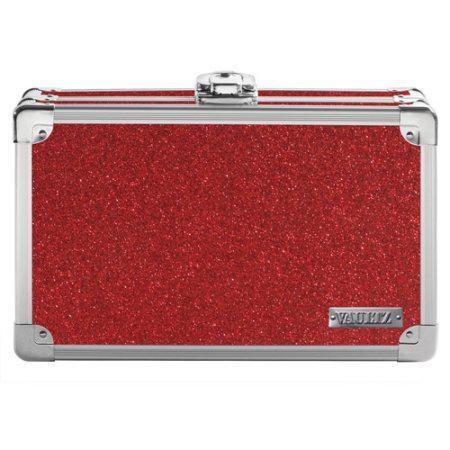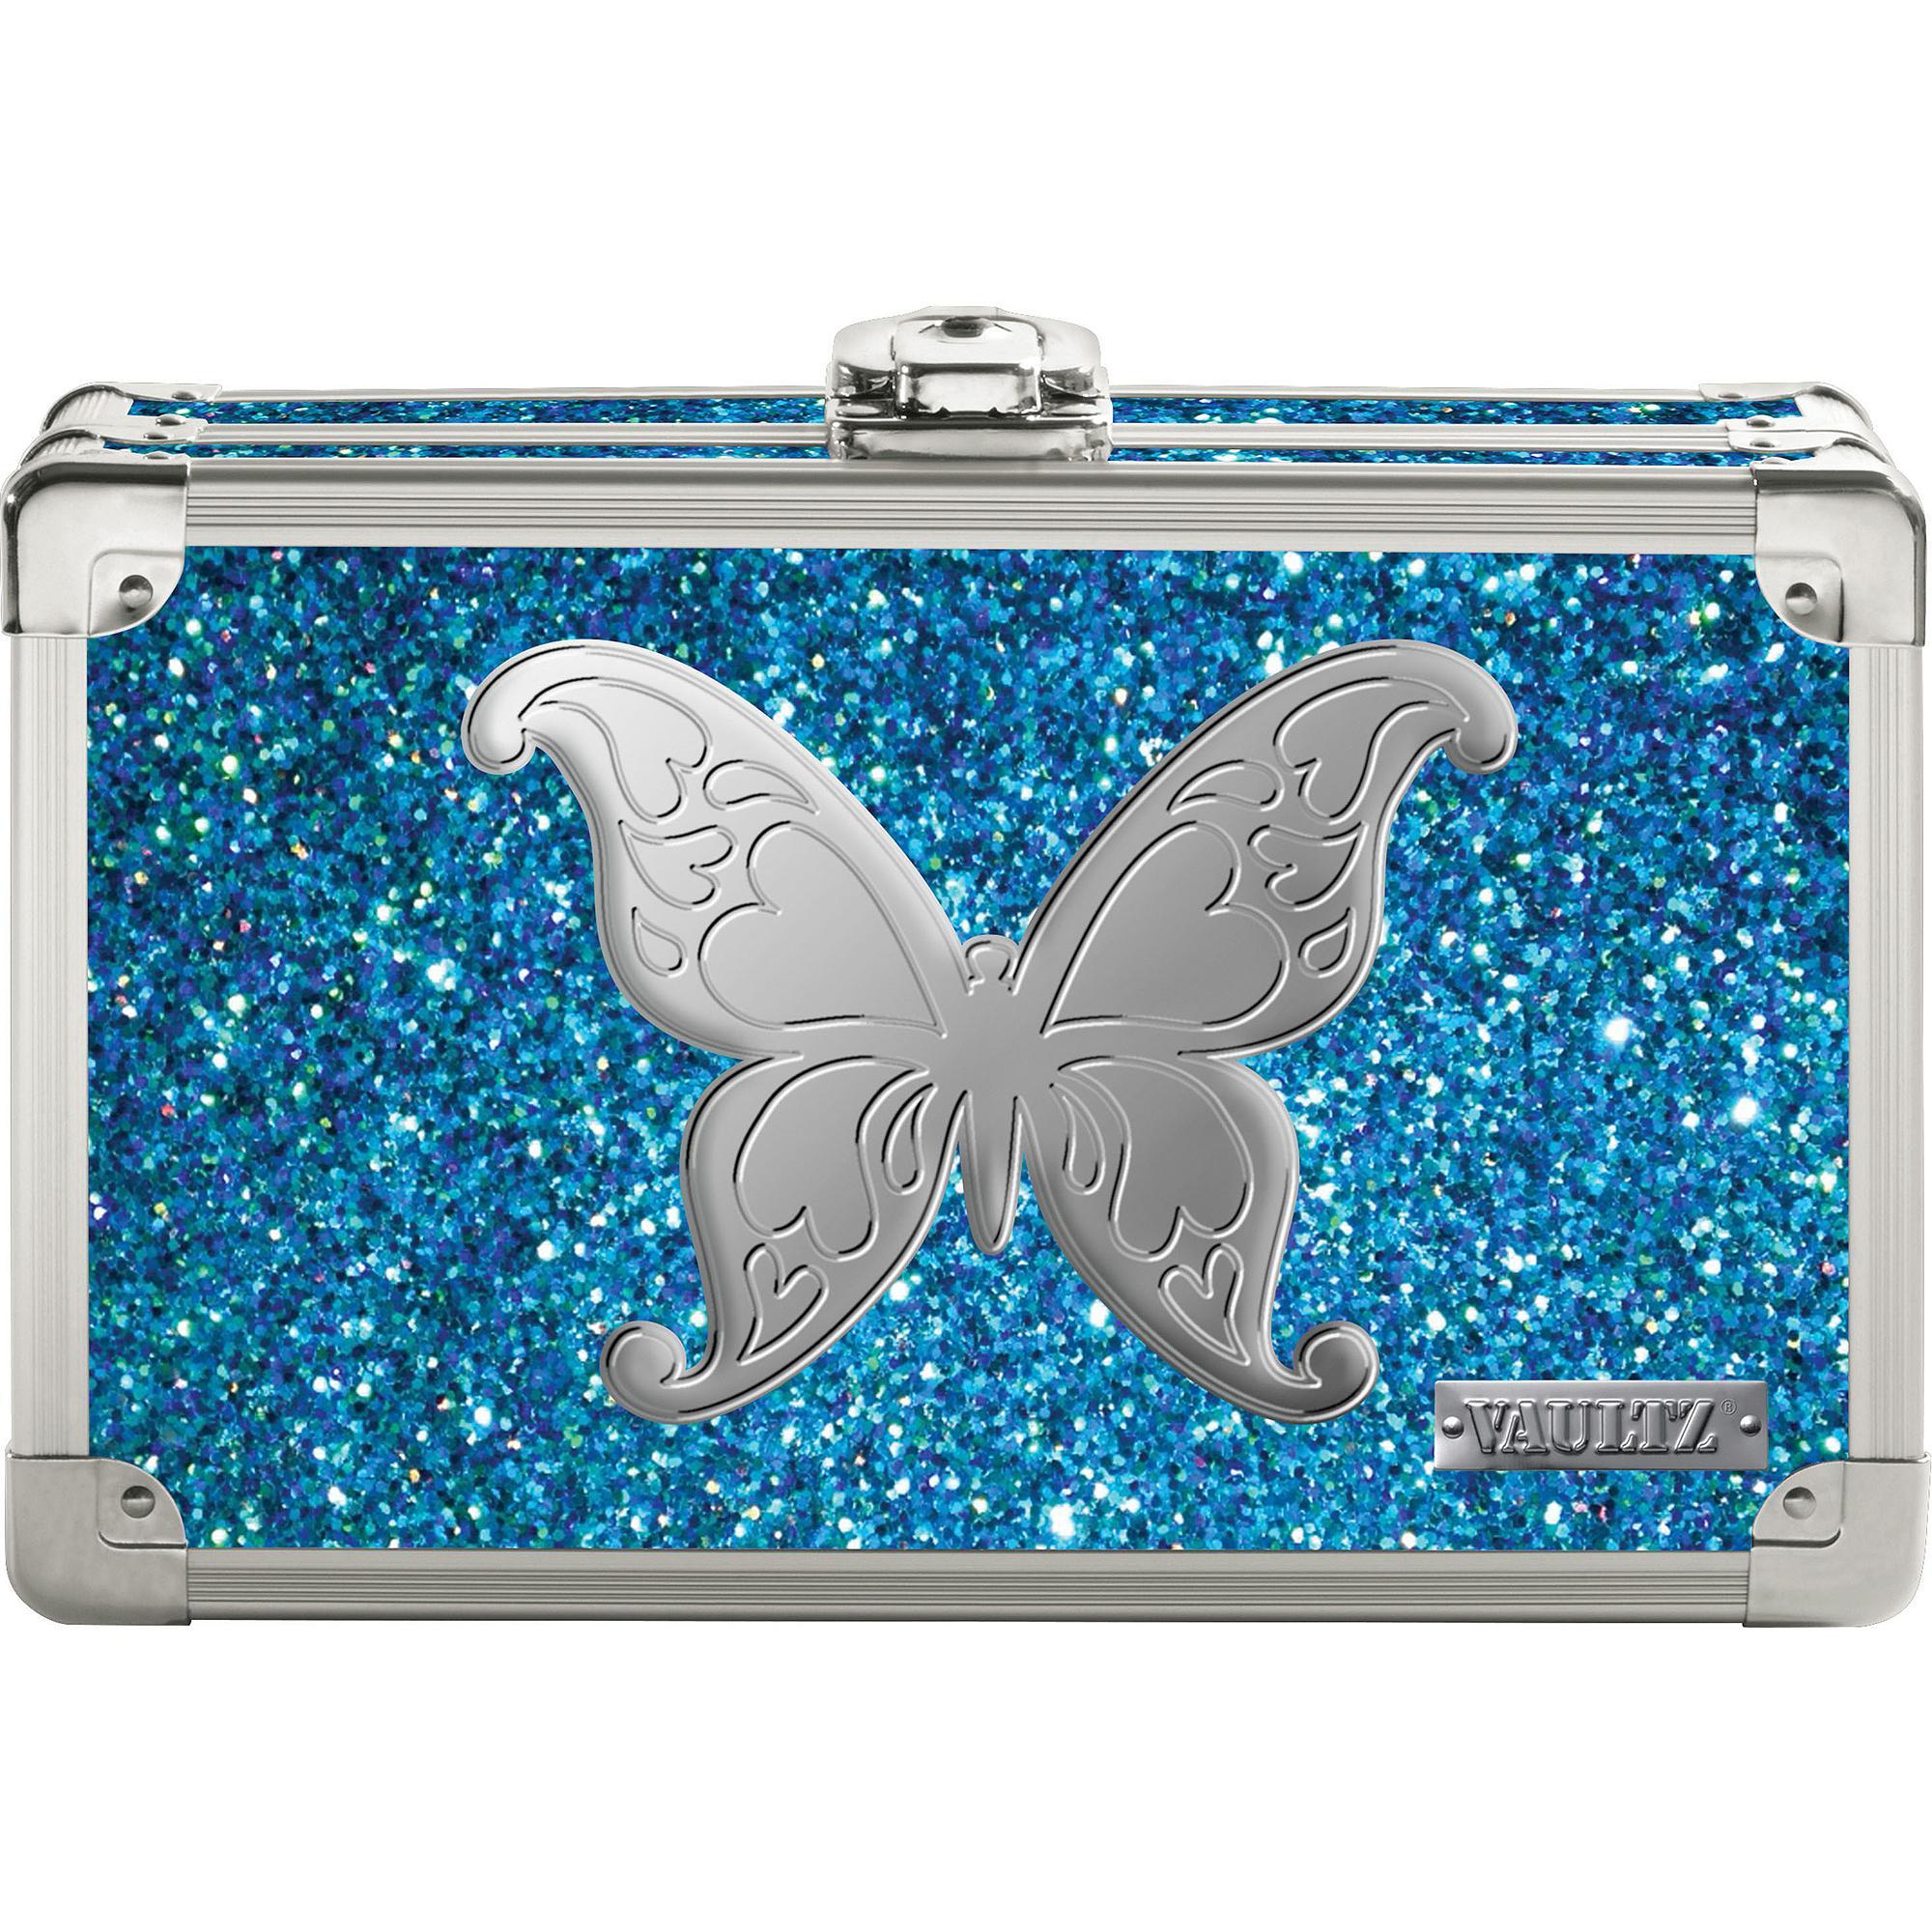The first image is the image on the left, the second image is the image on the right. Analyze the images presented: Is the assertion "In one of the images there is a suitcase that is sitting at a 45 degree angle." valid? Answer yes or no. No. The first image is the image on the left, the second image is the image on the right. Evaluate the accuracy of this statement regarding the images: "There is a batman logo.". Is it true? Answer yes or no. No. 